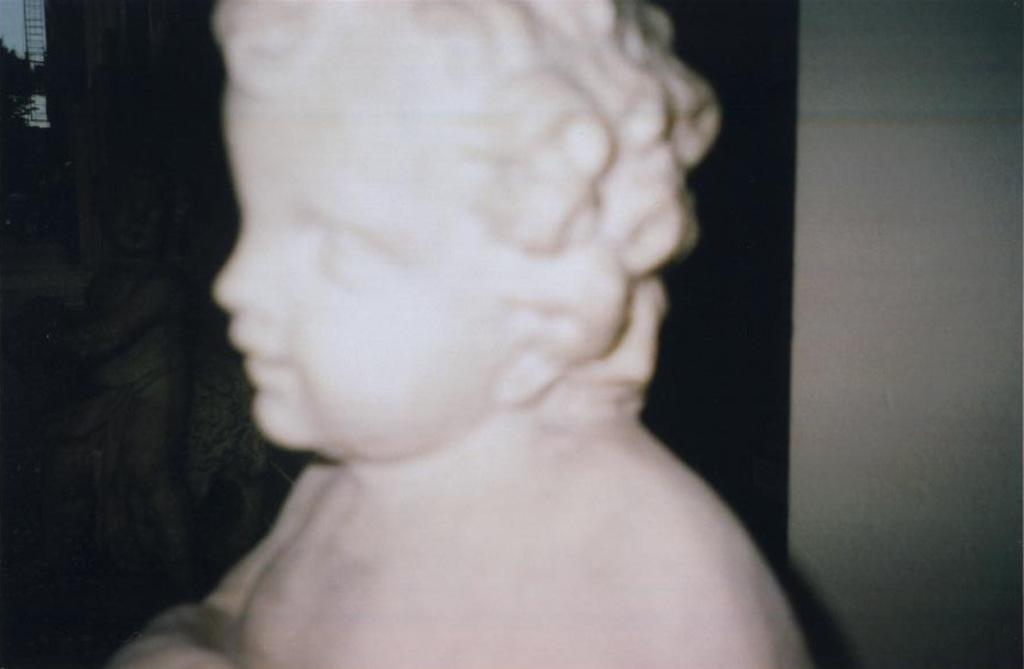What is the main subject of the image? There is a depiction of a boy in the center of the image. How many geese are flying in the background of the image? There are no geese present in the image; it features a depiction of a boy in the center. What type of range can be seen in the image? There is no range present in the image; it features a depiction of a boy in the center. 